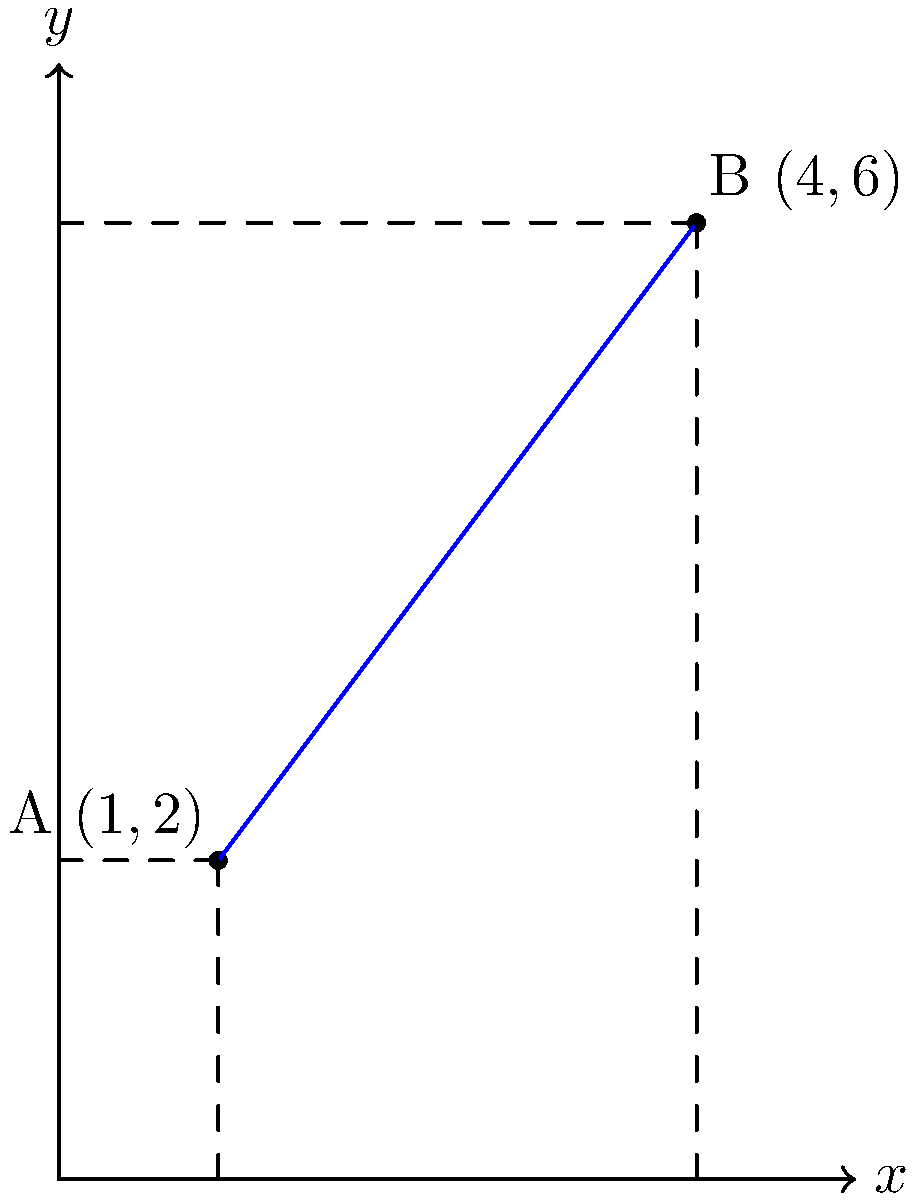You've created a unique sculpture using scrap metal, and two points on your artwork form a straight line. Point A is located at (1,2) and point B is at (4,6) on your coordinate grid. What is the slope of the line connecting these two points on your sculpture? To find the slope of the line connecting two points, we can use the slope formula:

$$ m = \frac{y_2 - y_1}{x_2 - x_1} $$

Where $(x_1, y_1)$ are the coordinates of the first point and $(x_2, y_2)$ are the coordinates of the second point.

Given:
Point A: $(1, 2)$, so $x_1 = 1$ and $y_1 = 2$
Point B: $(4, 6)$, so $x_2 = 4$ and $y_2 = 6$

Let's substitute these values into the slope formula:

$$ m = \frac{y_2 - y_1}{x_2 - x_1} = \frac{6 - 2}{4 - 1} = \frac{4}{3} $$

Therefore, the slope of the line connecting points A and B on your sculpture is $\frac{4}{3}$.
Answer: $\frac{4}{3}$ 